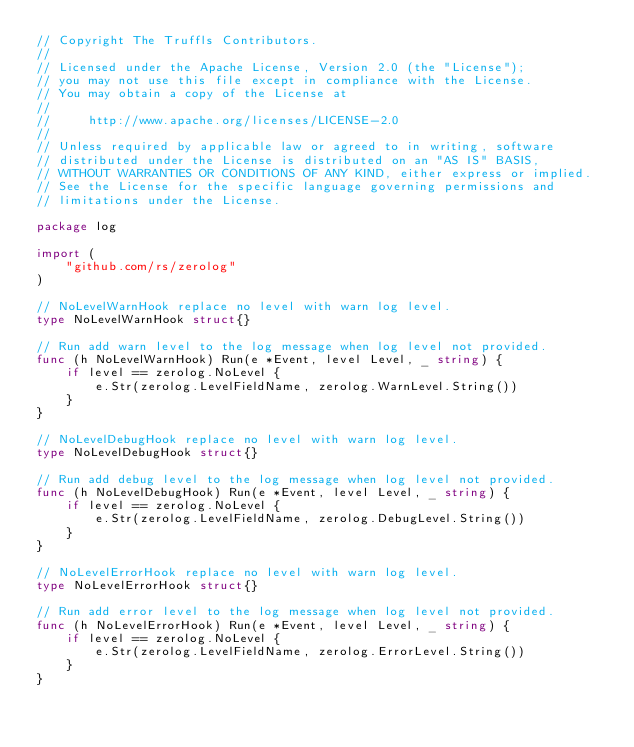Convert code to text. <code><loc_0><loc_0><loc_500><loc_500><_Go_>// Copyright The Truffls Contributors.
//
// Licensed under the Apache License, Version 2.0 (the "License");
// you may not use this file except in compliance with the License.
// You may obtain a copy of the License at
//
//     http://www.apache.org/licenses/LICENSE-2.0
//
// Unless required by applicable law or agreed to in writing, software
// distributed under the License is distributed on an "AS IS" BASIS,
// WITHOUT WARRANTIES OR CONDITIONS OF ANY KIND, either express or implied.
// See the License for the specific language governing permissions and
// limitations under the License.

package log

import (
	"github.com/rs/zerolog"
)

// NoLevelWarnHook replace no level with warn log level.
type NoLevelWarnHook struct{}

// Run add warn level to the log message when log level not provided.
func (h NoLevelWarnHook) Run(e *Event, level Level, _ string) {
	if level == zerolog.NoLevel {
		e.Str(zerolog.LevelFieldName, zerolog.WarnLevel.String())
	}
}

// NoLevelDebugHook replace no level with warn log level.
type NoLevelDebugHook struct{}

// Run add debug level to the log message when log level not provided.
func (h NoLevelDebugHook) Run(e *Event, level Level, _ string) {
	if level == zerolog.NoLevel {
		e.Str(zerolog.LevelFieldName, zerolog.DebugLevel.String())
	}
}

// NoLevelErrorHook replace no level with warn log level.
type NoLevelErrorHook struct{}

// Run add error level to the log message when log level not provided.
func (h NoLevelErrorHook) Run(e *Event, level Level, _ string) {
	if level == zerolog.NoLevel {
		e.Str(zerolog.LevelFieldName, zerolog.ErrorLevel.String())
	}
}
</code> 